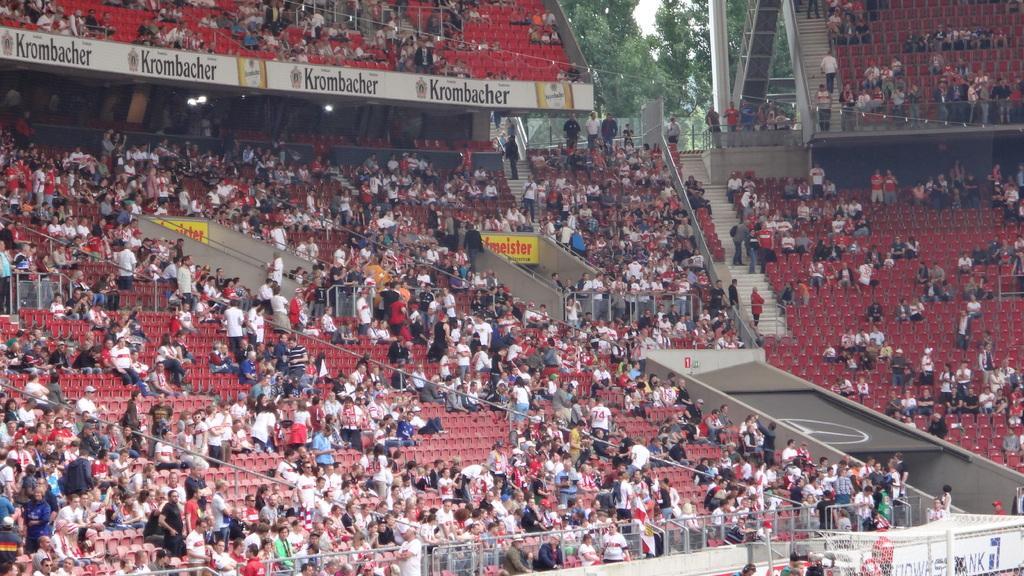How would you summarize this image in a sentence or two? In this picture we can see a group of people where some are sitting on chairs and some are standing, steps, lights, fence and in the background we can see trees. 